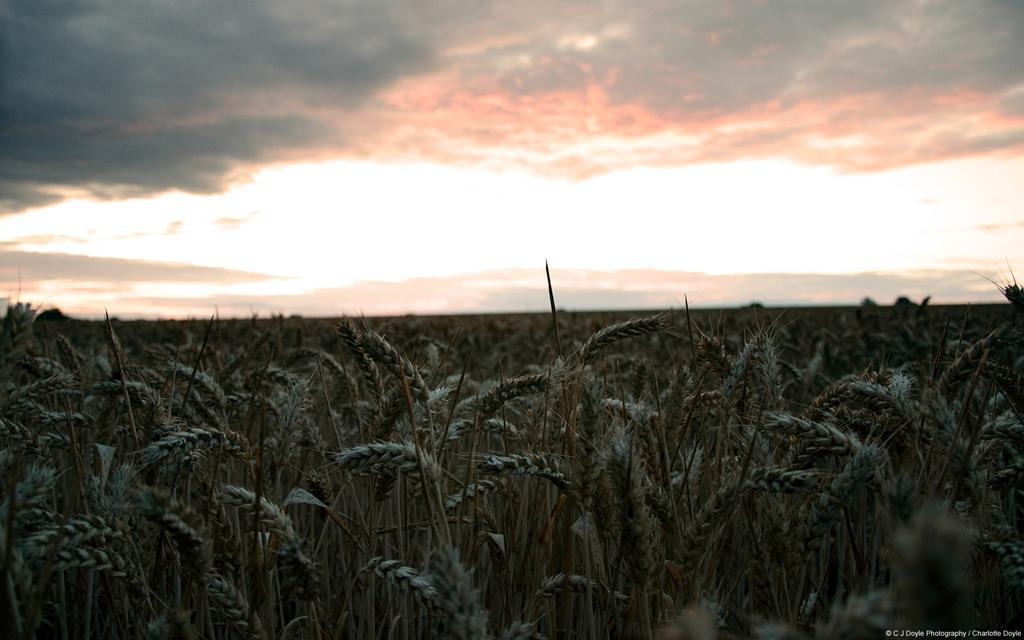What is the main subject of the image? The main subject of the image is many plants. What can be seen in the background of the image? There are clouds visible in the background of the image. What else is visible in the background of the image? The sky is visible in the background of the image. What type of reaction can be seen happening between the plants and the bear in the image? There is no bear present in the image, so no such reaction can be observed. 